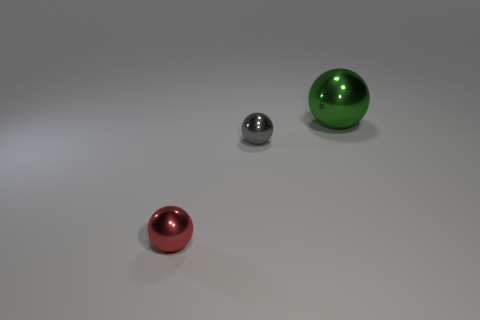How many big objects are either green objects or red things?
Give a very brief answer. 1. There is a tiny gray metal sphere; what number of red spheres are to the left of it?
Make the answer very short. 1. What is the color of the large metal thing that is the same shape as the tiny red object?
Your answer should be very brief. Green. What number of rubber things are either large yellow balls or small red spheres?
Ensure brevity in your answer.  0. Are there any tiny shiny things in front of the small metal ball behind the metal sphere in front of the small gray shiny thing?
Offer a terse response. Yes. The big sphere has what color?
Offer a terse response. Green. There is a small thing that is behind the tiny red sphere; is its shape the same as the red metallic object?
Give a very brief answer. Yes. How many objects are red balls or metal things in front of the gray sphere?
Your answer should be compact. 1. Are the thing that is in front of the tiny gray thing and the green ball made of the same material?
Make the answer very short. Yes. Is there any other thing that has the same size as the gray object?
Provide a short and direct response. Yes. 